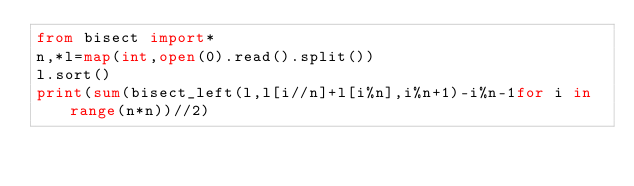Convert code to text. <code><loc_0><loc_0><loc_500><loc_500><_Python_>from bisect import*
n,*l=map(int,open(0).read().split())
l.sort()
print(sum(bisect_left(l,l[i//n]+l[i%n],i%n+1)-i%n-1for i in range(n*n))//2)</code> 